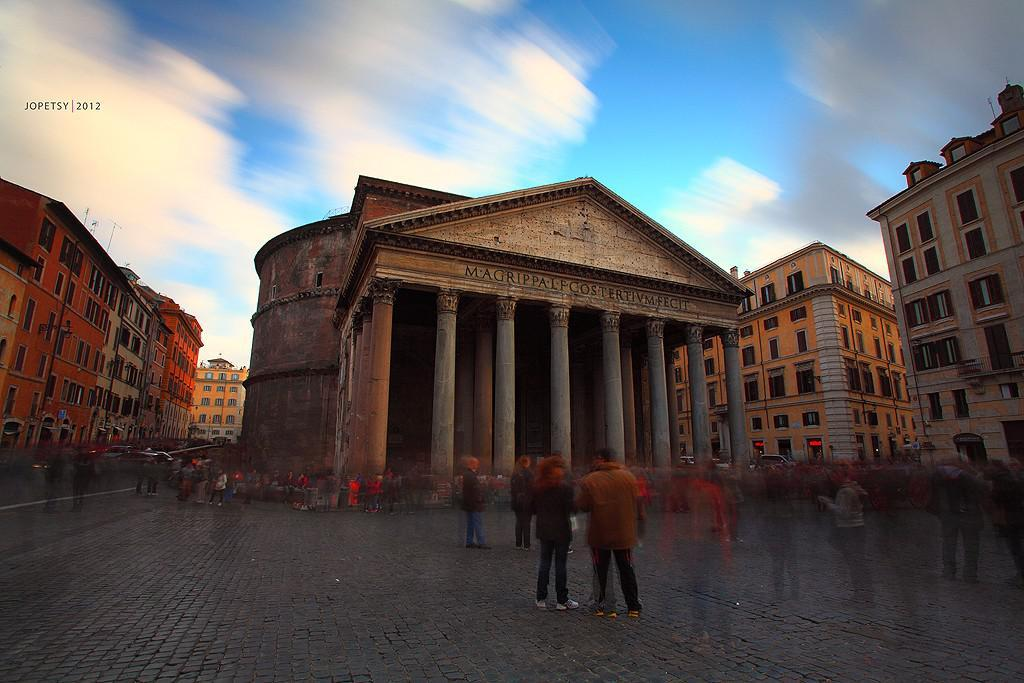What type of surface is visible in the image? There is ground visible in the image. What are the people in the image doing? The people standing on the ground suggest they might be waiting or observing something. What else can be seen in the image besides the ground and people? There are vehicles and buildings in the image. What is visible in the background of the image? The sky is visible in the background of the image. What book is the person reading during the recess in the image? There is no book or recess present in the image; it features people standing on the ground, vehicles, buildings, and the sky. 